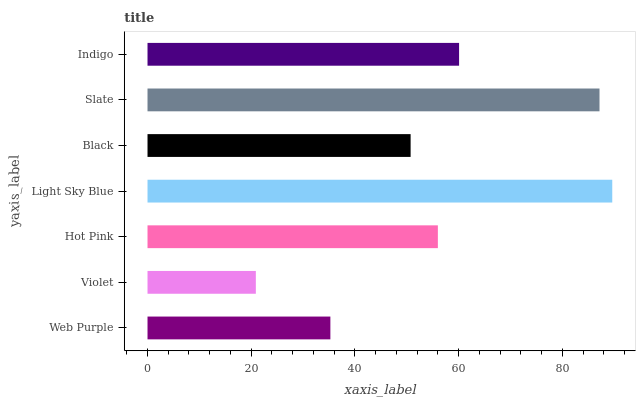Is Violet the minimum?
Answer yes or no. Yes. Is Light Sky Blue the maximum?
Answer yes or no. Yes. Is Hot Pink the minimum?
Answer yes or no. No. Is Hot Pink the maximum?
Answer yes or no. No. Is Hot Pink greater than Violet?
Answer yes or no. Yes. Is Violet less than Hot Pink?
Answer yes or no. Yes. Is Violet greater than Hot Pink?
Answer yes or no. No. Is Hot Pink less than Violet?
Answer yes or no. No. Is Hot Pink the high median?
Answer yes or no. Yes. Is Hot Pink the low median?
Answer yes or no. Yes. Is Light Sky Blue the high median?
Answer yes or no. No. Is Black the low median?
Answer yes or no. No. 